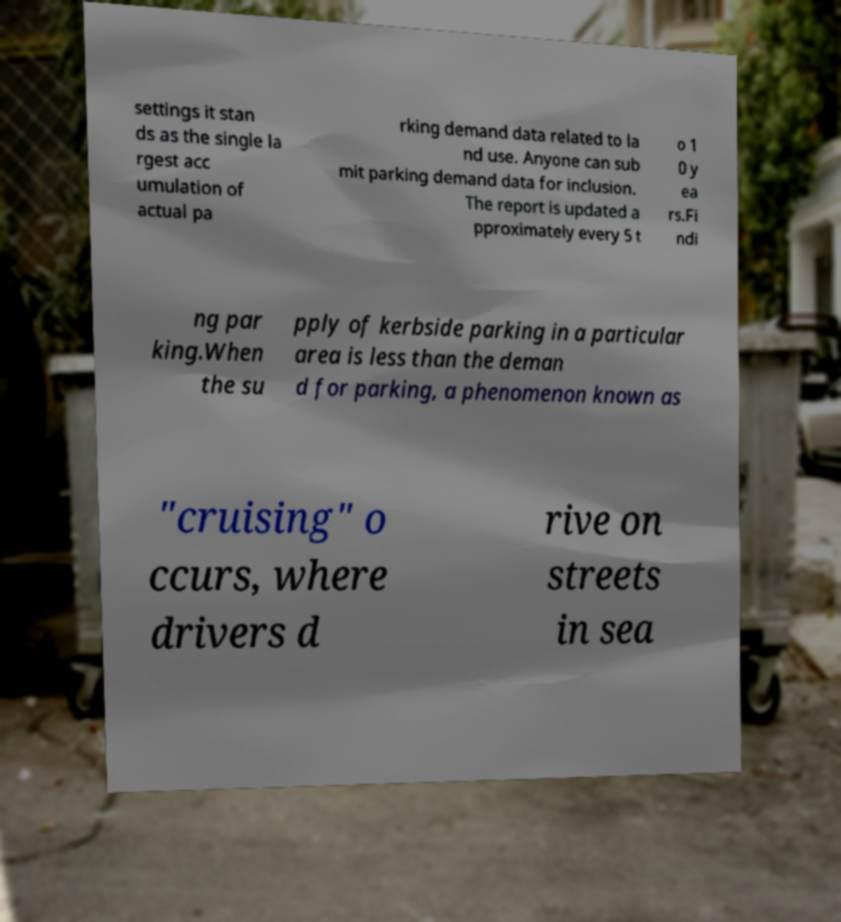Could you assist in decoding the text presented in this image and type it out clearly? settings it stan ds as the single la rgest acc umulation of actual pa rking demand data related to la nd use. Anyone can sub mit parking demand data for inclusion. The report is updated a pproximately every 5 t o 1 0 y ea rs.Fi ndi ng par king.When the su pply of kerbside parking in a particular area is less than the deman d for parking, a phenomenon known as "cruising" o ccurs, where drivers d rive on streets in sea 